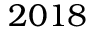Convert formula to latex. <formula><loc_0><loc_0><loc_500><loc_500>2 0 1 8</formula> 